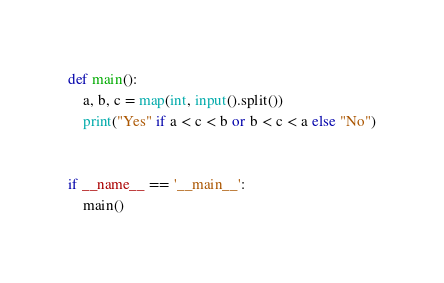<code> <loc_0><loc_0><loc_500><loc_500><_Python_>def main():
    a, b, c = map(int, input().split())
    print("Yes" if a < c < b or b < c < a else "No")


if __name__ == '__main__':
    main()

</code> 